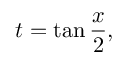<formula> <loc_0><loc_0><loc_500><loc_500>t = \tan { \frac { x } { 2 } } ,</formula> 